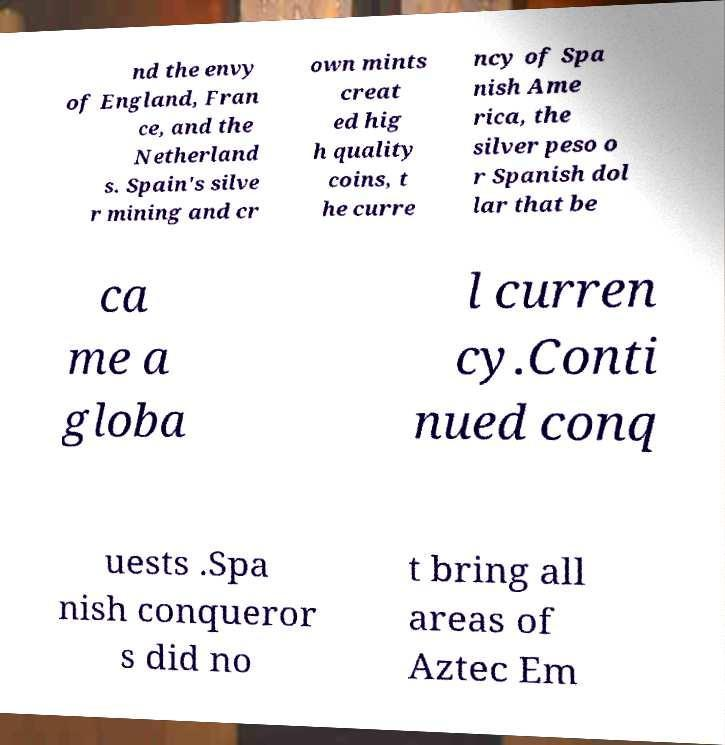Could you assist in decoding the text presented in this image and type it out clearly? nd the envy of England, Fran ce, and the Netherland s. Spain's silve r mining and cr own mints creat ed hig h quality coins, t he curre ncy of Spa nish Ame rica, the silver peso o r Spanish dol lar that be ca me a globa l curren cy.Conti nued conq uests .Spa nish conqueror s did no t bring all areas of Aztec Em 